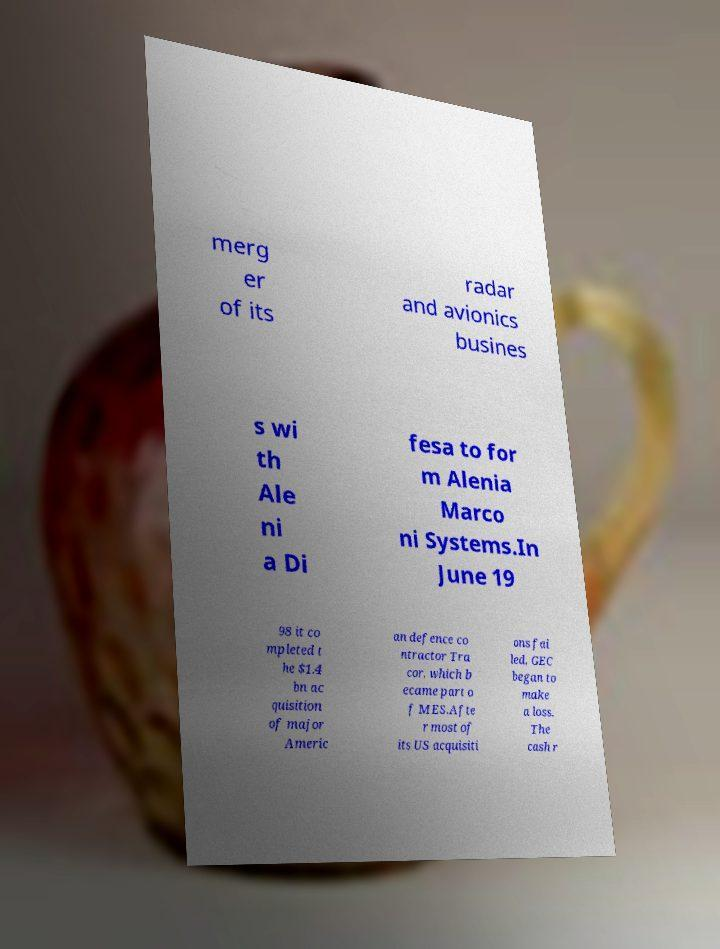Can you read and provide the text displayed in the image?This photo seems to have some interesting text. Can you extract and type it out for me? merg er of its radar and avionics busines s wi th Ale ni a Di fesa to for m Alenia Marco ni Systems.In June 19 98 it co mpleted t he $1.4 bn ac quisition of major Americ an defence co ntractor Tra cor, which b ecame part o f MES.Afte r most of its US acquisiti ons fai led, GEC began to make a loss. The cash r 